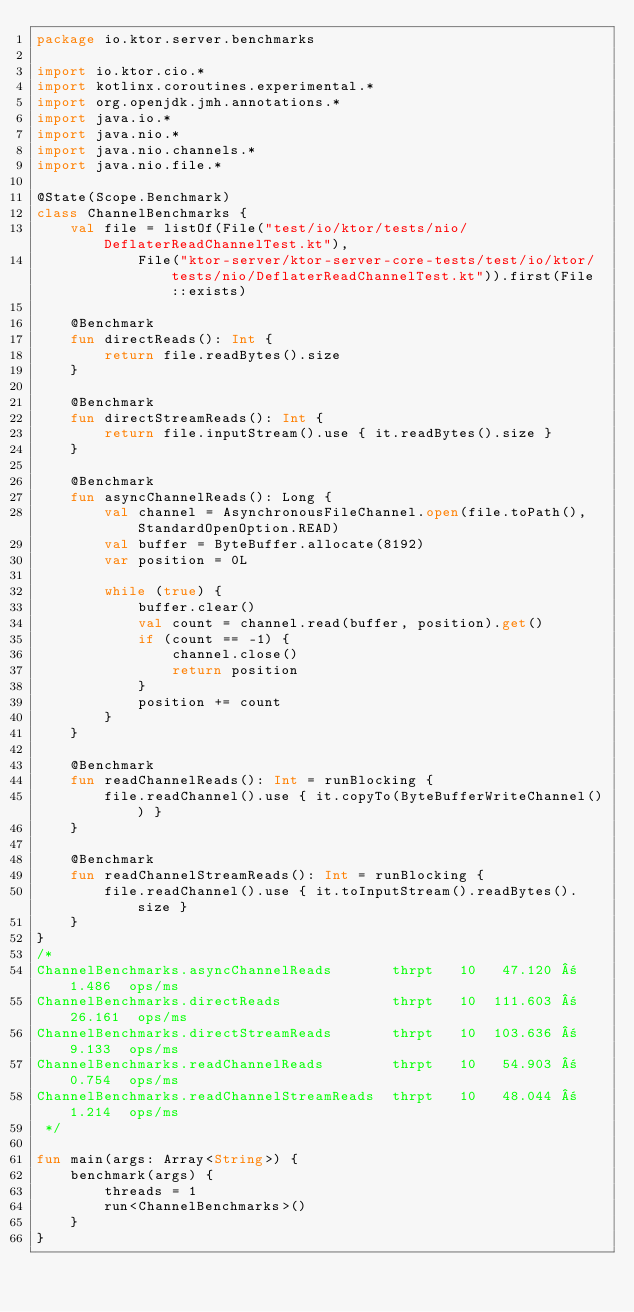Convert code to text. <code><loc_0><loc_0><loc_500><loc_500><_Kotlin_>package io.ktor.server.benchmarks

import io.ktor.cio.*
import kotlinx.coroutines.experimental.*
import org.openjdk.jmh.annotations.*
import java.io.*
import java.nio.*
import java.nio.channels.*
import java.nio.file.*

@State(Scope.Benchmark)
class ChannelBenchmarks {
    val file = listOf(File("test/io/ktor/tests/nio/DeflaterReadChannelTest.kt"),
            File("ktor-server/ktor-server-core-tests/test/io/ktor/tests/nio/DeflaterReadChannelTest.kt")).first(File::exists)

    @Benchmark
    fun directReads(): Int {
        return file.readBytes().size
    }

    @Benchmark
    fun directStreamReads(): Int {
        return file.inputStream().use { it.readBytes().size }
    }

    @Benchmark
    fun asyncChannelReads(): Long {
        val channel = AsynchronousFileChannel.open(file.toPath(), StandardOpenOption.READ)
        val buffer = ByteBuffer.allocate(8192)
        var position = 0L

        while (true) {
            buffer.clear()
            val count = channel.read(buffer, position).get()
            if (count == -1) {
                channel.close()
                return position
            }
            position += count
        }
    }

    @Benchmark
    fun readChannelReads(): Int = runBlocking {
        file.readChannel().use { it.copyTo(ByteBufferWriteChannel()) }
    }

    @Benchmark
    fun readChannelStreamReads(): Int = runBlocking {
        file.readChannel().use { it.toInputStream().readBytes().size }
    }
}
/*
ChannelBenchmarks.asyncChannelReads       thrpt   10   47.120 ±  1.486  ops/ms
ChannelBenchmarks.directReads             thrpt   10  111.603 ± 26.161  ops/ms
ChannelBenchmarks.directStreamReads       thrpt   10  103.636 ±  9.133  ops/ms
ChannelBenchmarks.readChannelReads        thrpt   10   54.903 ±  0.754  ops/ms
ChannelBenchmarks.readChannelStreamReads  thrpt   10   48.044 ±  1.214  ops/ms
 */

fun main(args: Array<String>) {
    benchmark(args) {
        threads = 1
        run<ChannelBenchmarks>()
    }
}</code> 